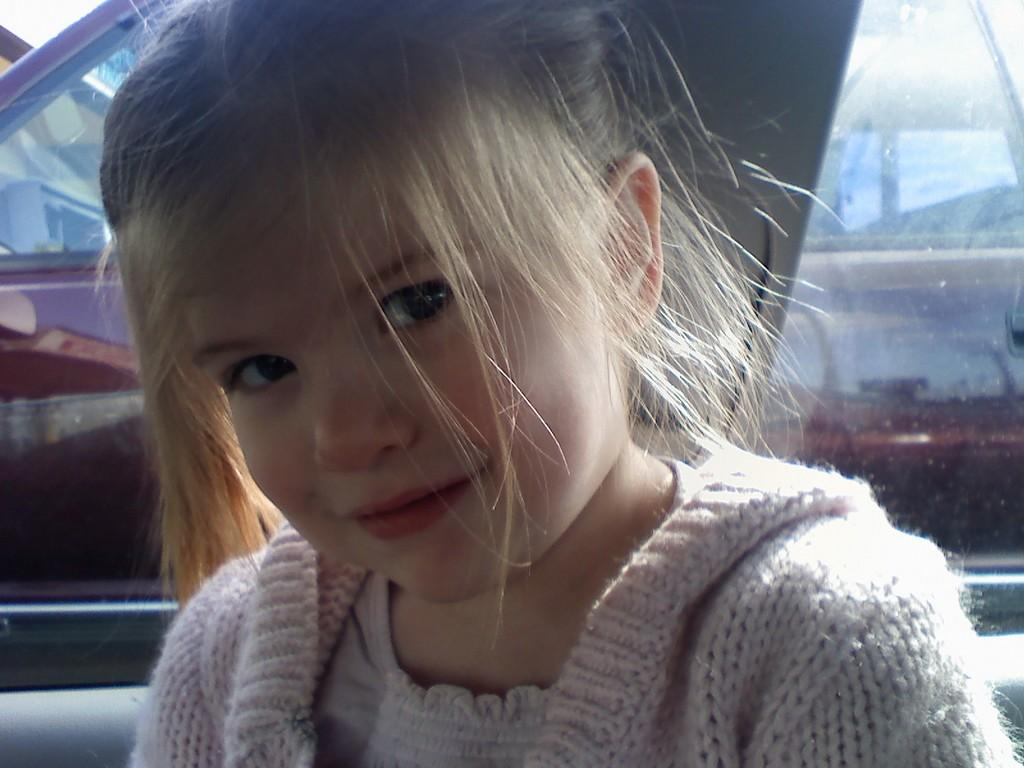Who is present in the image? There is a girl in the image. Where is the girl located? The girl is inside a car. What can be seen behind the girl? There is a car window behind the girl. What is visible through the car window? There is another car visible behind the car window. What type of fear does the girl have in the image? There is no indication of fear in the image; the girl is simply inside a car. What color is the spot on the car window? There is no spot visible on the car window in the image. 